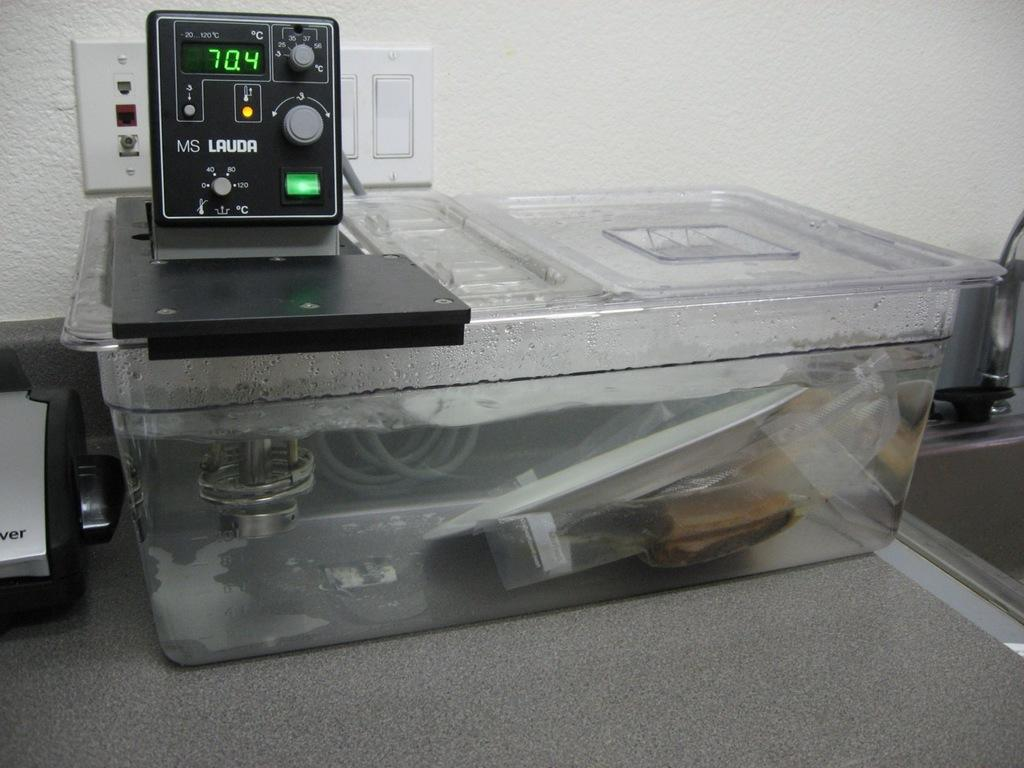Provide a one-sentence caption for the provided image. A device that reads a temperature of 70.4. 